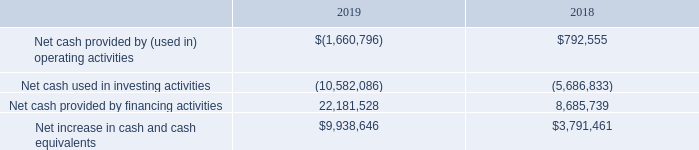Liquidity and Capital Resources
As of December 31, 2019, we had total current assets of approximately $27.1 million, compared with current liabilities of approximately $6.1 million, resulting in working capital of approximately $21.0 million and a current ratio of approximately 4.4 to 1. This compares with the working capital balance of approximately $11.5 million and the current ratio of 3.7 to 1 at December 31, 2018. This increase in working capital, as discussed in more detail below, is primarily the result of the capital we raised in 2019.
Following is a table with summary data from the consolidated statement of cash flows for the years ended December 31, 2019 and 2018, as presented.
Our operating activities used approximately $1.7 million in the year ended December 31, 2019, as compared with approximately $0.8 million provided by operating activities in the year ended December 31, 2018. The cash provided in 2018 was the result of our net income and non-cash expenses, partially offset by the increased working capital required to support higher revenues. The cash used in operations in 2019 was the result of increased levels of working capital required to support higher revenue levels, expenditures related to growth, and costs associated with our acquisition in 2019.
We used approximately $5.7 million in investing activities in the year ended December 31, 2018, as compared with approximately $10.6 million used in investing activities in the year ended December 31, 2019. The majority of the investing activities in 2018 related to our acquisition of CareSpeak communications in October 2018. The majority of investing in activities in 2019 related to our acquisitions of RMDY Health, Inc. in 2019, as well as a software purchase in 2019.
Financing activities provided $8.7 million in the year ended December 31, 2018, as compared with $22.2 million in the year ended December 31, 2019. The cash provided in 2018 was primarily the result of the equity raised in connection with our uplisting to Nasdaq, as well as from the proceeds of option exercises. The cash used in 2019 was the result of our underwritten offering in 2019, as well as from the proceeds of option exercises.
With our cash on hand, we have sufficient cash to operate our business for more than the next 12 months and we do not anticipate the need to raise additional equity for operating purposes.
What were the Net cash provided by financing activities in 2018 and 2019 respectively? 8,685,739, 22,181,528. What were the net increases in cash and cash equivalents in 2018 and 2019, respectively? $3,791,461, $9,938,646. What is the percentage change in the net increase in cash and cash equivalents from 2018 to 2019?
Answer scale should be: percent. (9,938,646-3,791,461)/3,791,461 
Answer: 162.13. What is the average net cash provided by financing activities from 2018 to 2019? (22,181,528+8,685,739)/2 
Answer: 15433633.5. What is the ratio of net cash used in investing activities from 2018 to 2019? -5,686,833/-10,582,086 
Answer: 0.54. What were the total current assets and liabilities as of December 31, 2019? Approximately $27.1 million, approximately $6.1 million. 